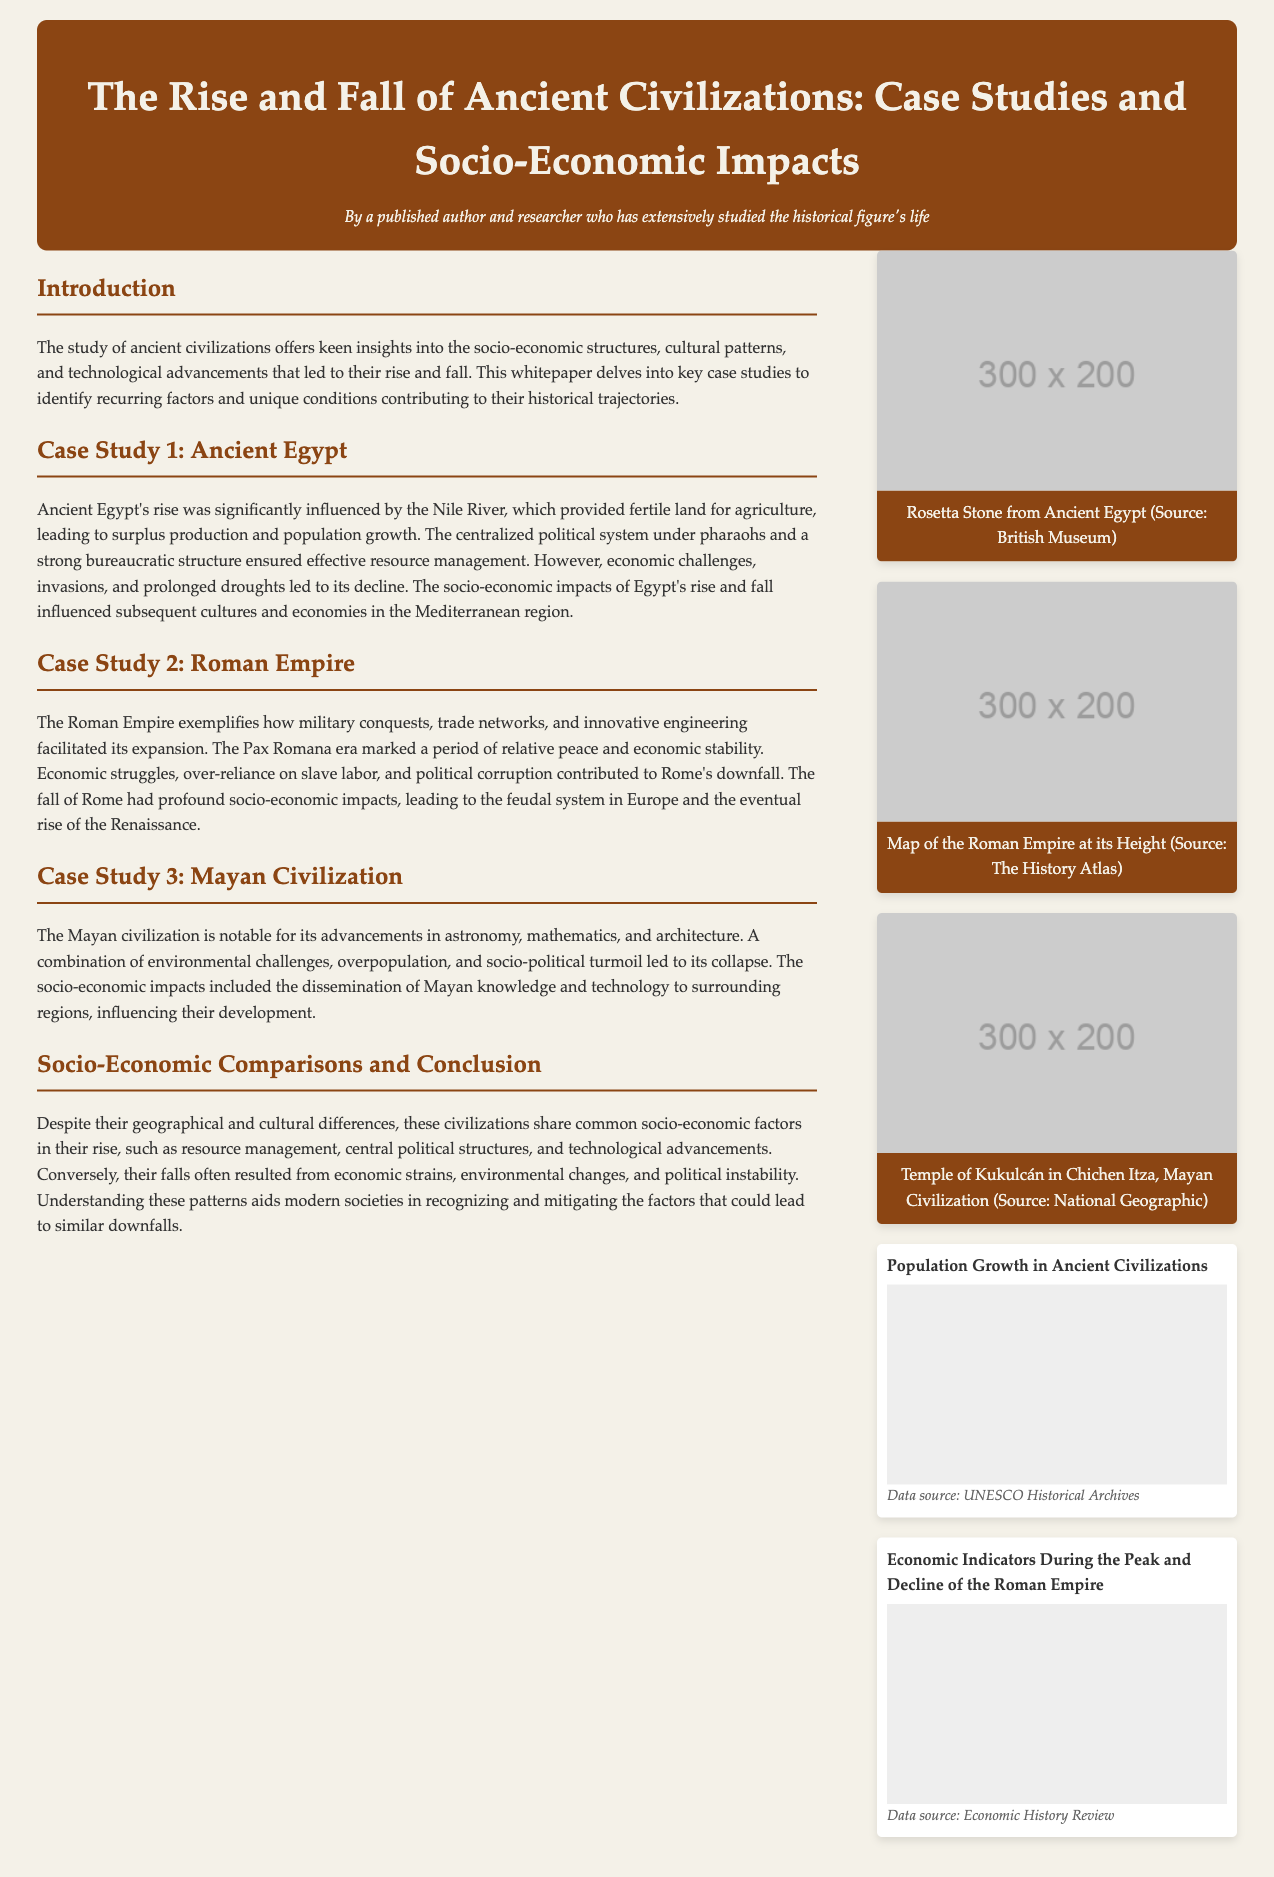What civilization is primarily discussed in the first case study? The first case study focuses on Ancient Egypt, detailing its rise and eventual decline.
Answer: Ancient Egypt What river was crucial for the rise of Ancient Egypt? The document states that the Nile River provided fertile land, significantly influencing Egypt's agricultural success.
Answer: Nile River What does the Pax Romana refer to in the context of the Roman Empire? The Pax Romana is described as a period of relative peace and economic stability during the Roman Empire's expansion.
Answer: Relative peace Which civilization is noted for advancements in astronomy and mathematics? The document highlights the Mayan civilization for its significant achievements in these fields.
Answer: Mayan civilization What led to the decline of the Roman Empire? The whitepaper identifies economic struggles, over-reliance on slave labor, and political corruption as contributing factors to Rome's downfall.
Answer: Economic struggles What kind of impacts did the fall of Ancient Egypt have on subsequent cultures? The socio-economic impacts of Egypt's decline influenced the economies and cultures in the Mediterranean region.
Answer: Mediterranean region What type of data does the chart titled "Economic Indicators During the Peak and Decline of the Roman Empire" likely represent? The chart title suggests it focuses on economic indicators regarding the Roman Empire's economic conditions at different times.
Answer: Economic indicators Where can one find the source of the chart comparing population growth? The document notes that the data source for the population growth chart is the UNESCO Historical Archives.
Answer: UNESCO Historical Archives 